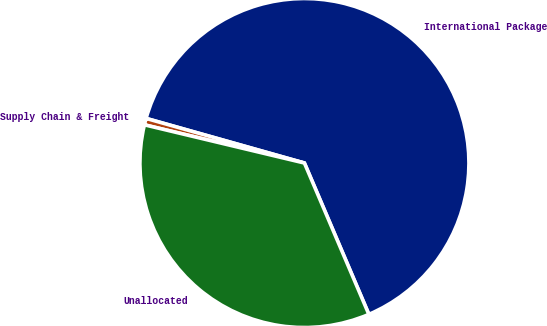Convert chart. <chart><loc_0><loc_0><loc_500><loc_500><pie_chart><fcel>International Package<fcel>Supply Chain & Freight<fcel>Unallocated<nl><fcel>64.22%<fcel>0.64%<fcel>35.14%<nl></chart> 